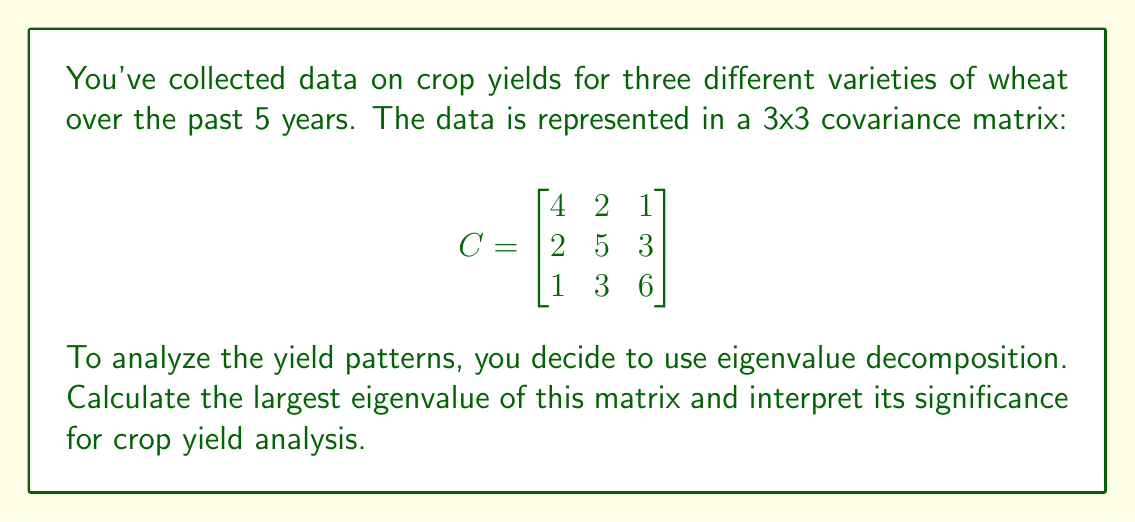What is the answer to this math problem? To find the eigenvalues of the covariance matrix C, we need to solve the characteristic equation:

$$\det(C - \lambda I) = 0$$

where $\lambda$ represents the eigenvalues and $I$ is the 3x3 identity matrix.

Step 1: Set up the characteristic equation:

$$\det\begin{bmatrix}
4-\lambda & 2 & 1 \\
2 & 5-\lambda & 3 \\
1 & 3 & 6-\lambda
\end{bmatrix} = 0$$

Step 2: Expand the determinant:

$$(4-\lambda)((5-\lambda)(6-\lambda)-9) - 2(2(6-\lambda)-3) + 1(2\cdot3-(5-\lambda)) = 0$$

Step 3: Simplify the equation:

$$-\lambda^3 + 15\lambda^2 - 66\lambda + 80 = 0$$

Step 4: This cubic equation is difficult to solve by hand, so we would typically use numerical methods or computer software to find the roots. The three eigenvalues are approximately:

$$\lambda_1 \approx 8.90$$
$$\lambda_2 \approx 4.76$$
$$\lambda_3 \approx 1.34$$

The largest eigenvalue is $\lambda_1 \approx 8.90$.

Interpretation: In crop yield analysis, the largest eigenvalue represents the direction of maximum variance in the data. A larger eigenvalue indicates a stronger pattern or trend in the yield data. The corresponding eigenvector would show which combination of wheat varieties contributes most to this pattern.

For a farmer, this means that focusing on the wheat varieties associated with the largest eigenvalue could potentially lead to more consistent or higher yields, as these varieties show the most significant variation and thus potential for optimization.
Answer: 8.90 